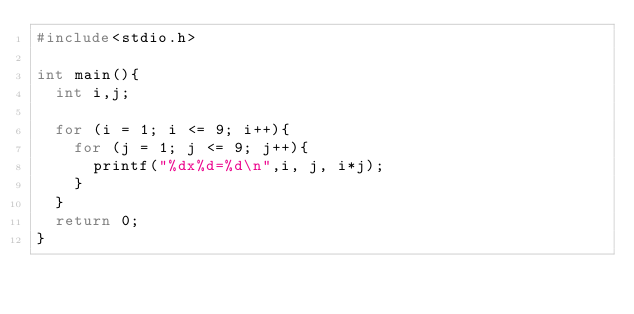Convert code to text. <code><loc_0><loc_0><loc_500><loc_500><_C_>#include<stdio.h>

int main(){
	int i,j;

	for (i = 1; i <= 9; i++){
		for (j = 1; j <= 9; j++){
			printf("%dx%d=%d\n",i, j, i*j);
		}
	}
	return 0;
}</code> 